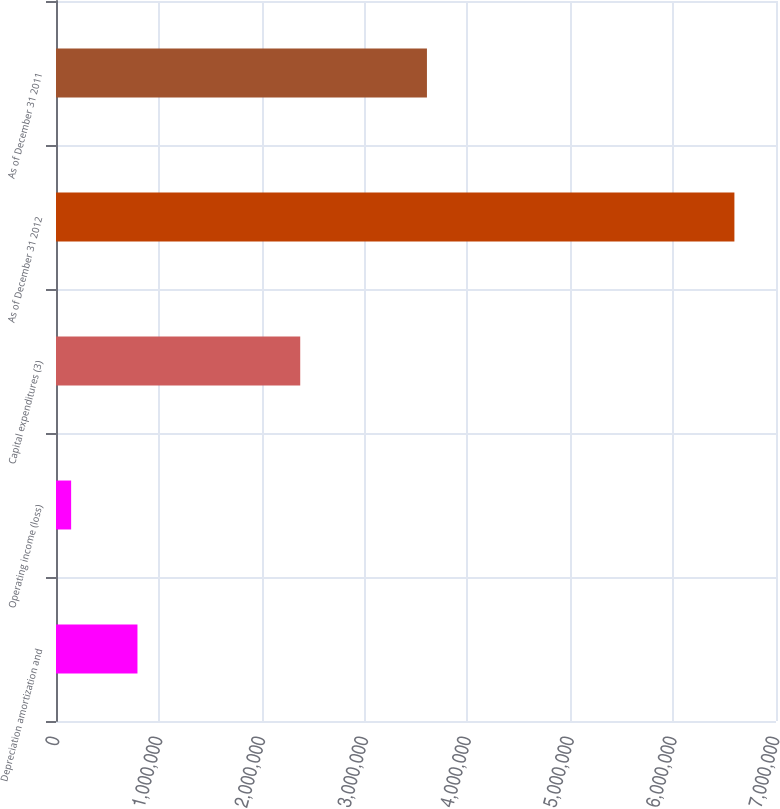Convert chart to OTSL. <chart><loc_0><loc_0><loc_500><loc_500><bar_chart><fcel>Depreciation amortization and<fcel>Operating income (loss)<fcel>Capital expenditures (3)<fcel>As of December 31 2012<fcel>As of December 31 2011<nl><fcel>791993<fcel>147146<fcel>2.37443e+06<fcel>6.59562e+06<fcel>3.6064e+06<nl></chart> 